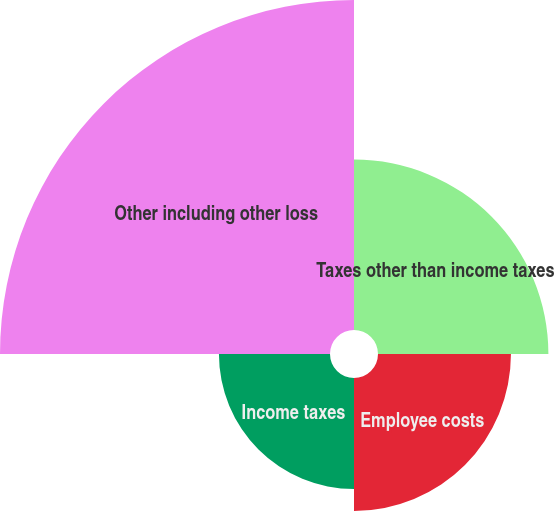<chart> <loc_0><loc_0><loc_500><loc_500><pie_chart><fcel>Taxes other than income taxes<fcel>Employee costs<fcel>Income taxes<fcel>Other including other loss<nl><fcel>22.89%<fcel>17.86%<fcel>14.92%<fcel>44.33%<nl></chart> 